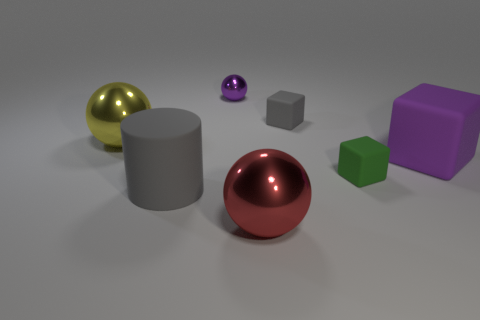What number of objects are either big shiny spheres or matte objects that are behind the tiny green block?
Your answer should be very brief. 4. Are there any other things that have the same material as the tiny gray thing?
Keep it short and to the point. Yes. The big object that is the same color as the small metallic ball is what shape?
Ensure brevity in your answer.  Cube. What is the material of the purple sphere?
Provide a succinct answer. Metal. Are the big purple object and the yellow sphere made of the same material?
Offer a very short reply. No. How many matte things are cylinders or purple spheres?
Your answer should be compact. 1. There is a purple thing that is in front of the small purple metallic ball; what is its shape?
Make the answer very short. Cube. There is a yellow object that is made of the same material as the big red ball; what is its size?
Provide a short and direct response. Large. What shape is the thing that is both in front of the small purple metal ball and behind the yellow shiny thing?
Make the answer very short. Cube. There is a big sphere that is in front of the big purple thing; does it have the same color as the big matte cylinder?
Offer a terse response. No. 